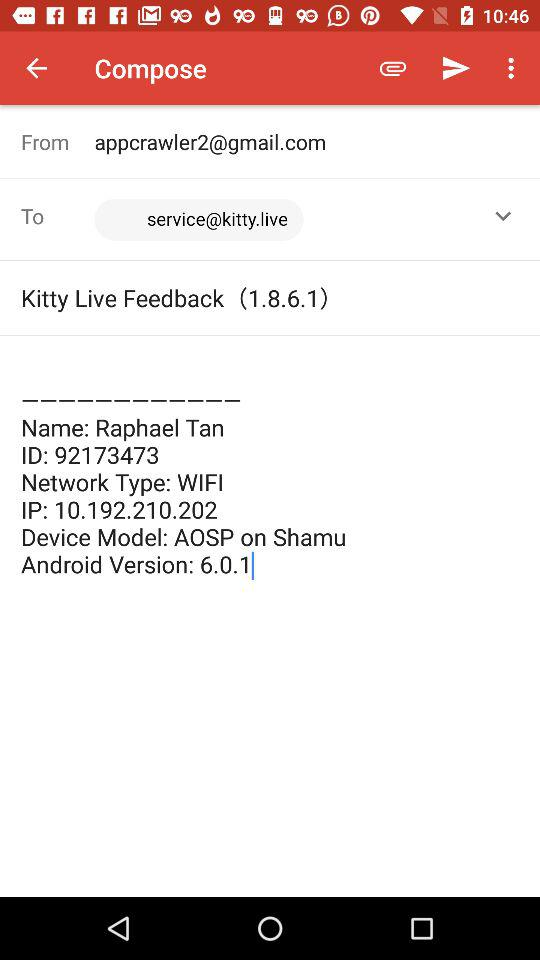What is the name of a person? The name of the person is Raphael Tan. 